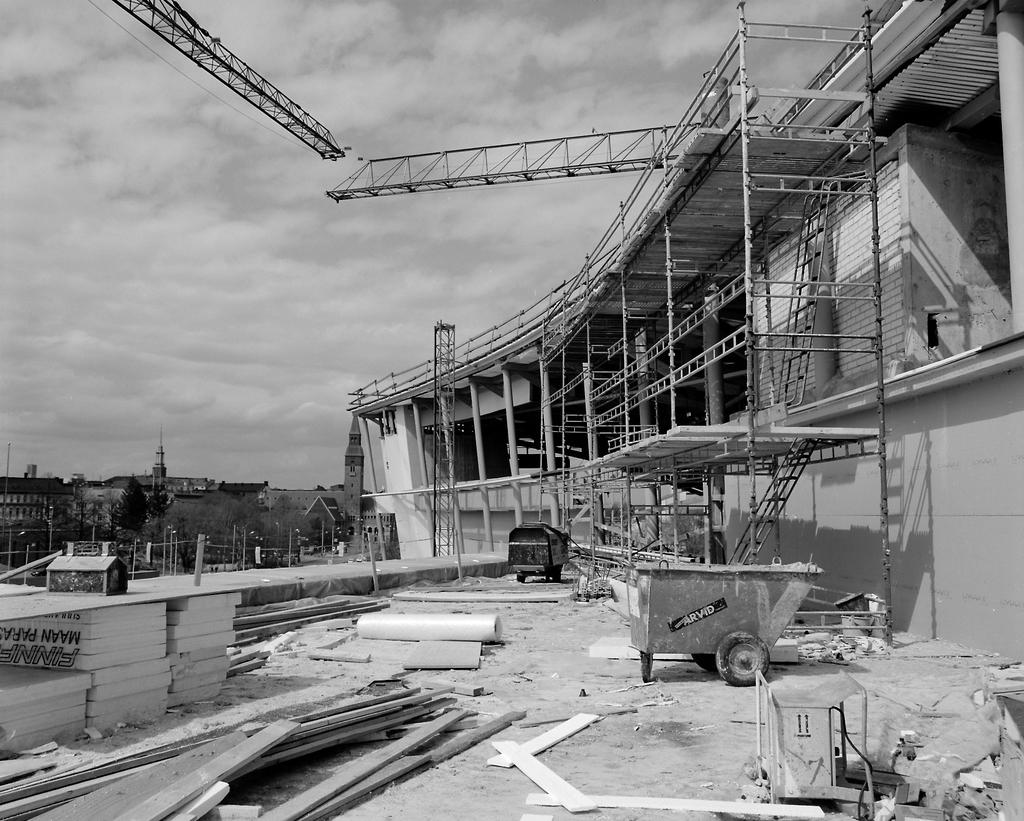What is the weather like in the image? The sky in the image is cloudy. What type of structures can be seen in the image? There are crane towers in the image. What are some other objects present in the image? Rods, poles, trees, a vehicle, a cart, and walls are visible in the image. Can you describe the unspecified things in the image? Unfortunately, the provided facts do not specify the nature of the unspecified things in the image. What type of appliance is being used to care for the plants in the image? There is no appliance or plants present in the image. Can you tell me how many drawers are visible in the image? There are no drawers present in the image. 